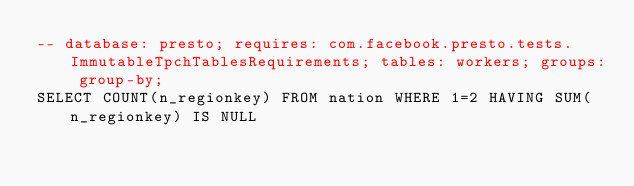<code> <loc_0><loc_0><loc_500><loc_500><_SQL_>-- database: presto; requires: com.facebook.presto.tests.ImmutableTpchTablesRequirements; tables: workers; groups: group-by;
SELECT COUNT(n_regionkey) FROM nation WHERE 1=2 HAVING SUM(n_regionkey) IS NULL
</code> 